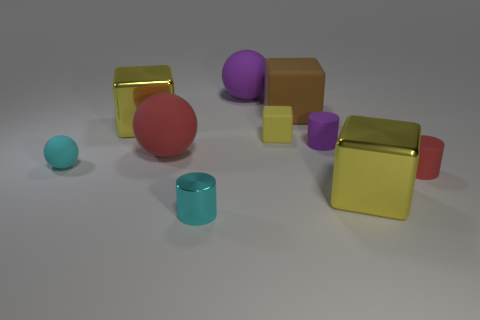There is a yellow shiny block right of the big brown rubber object; what size is it? The yellow shiny block to the right of the large brown rubber-like object appears to be a medium-sized cube relative to the other objects in the scene. 